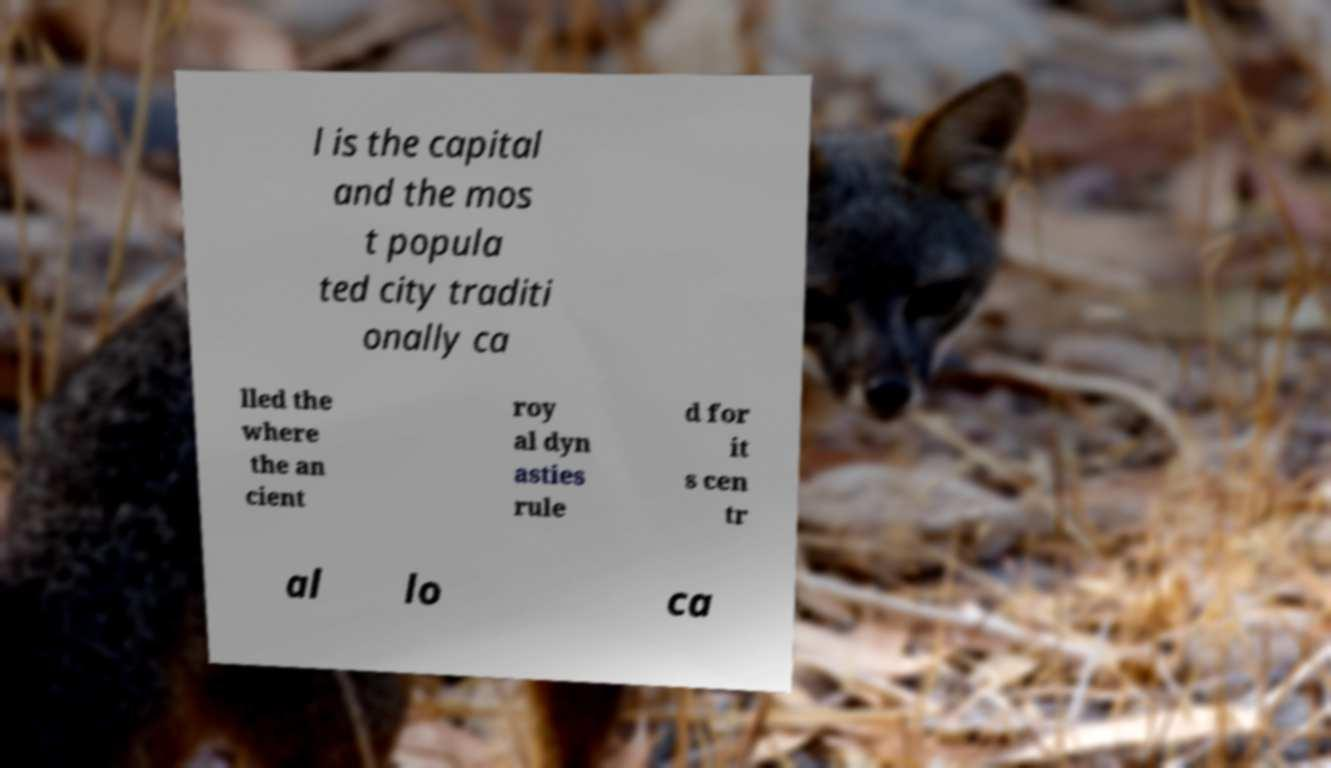What messages or text are displayed in this image? I need them in a readable, typed format. l is the capital and the mos t popula ted city traditi onally ca lled the where the an cient roy al dyn asties rule d for it s cen tr al lo ca 